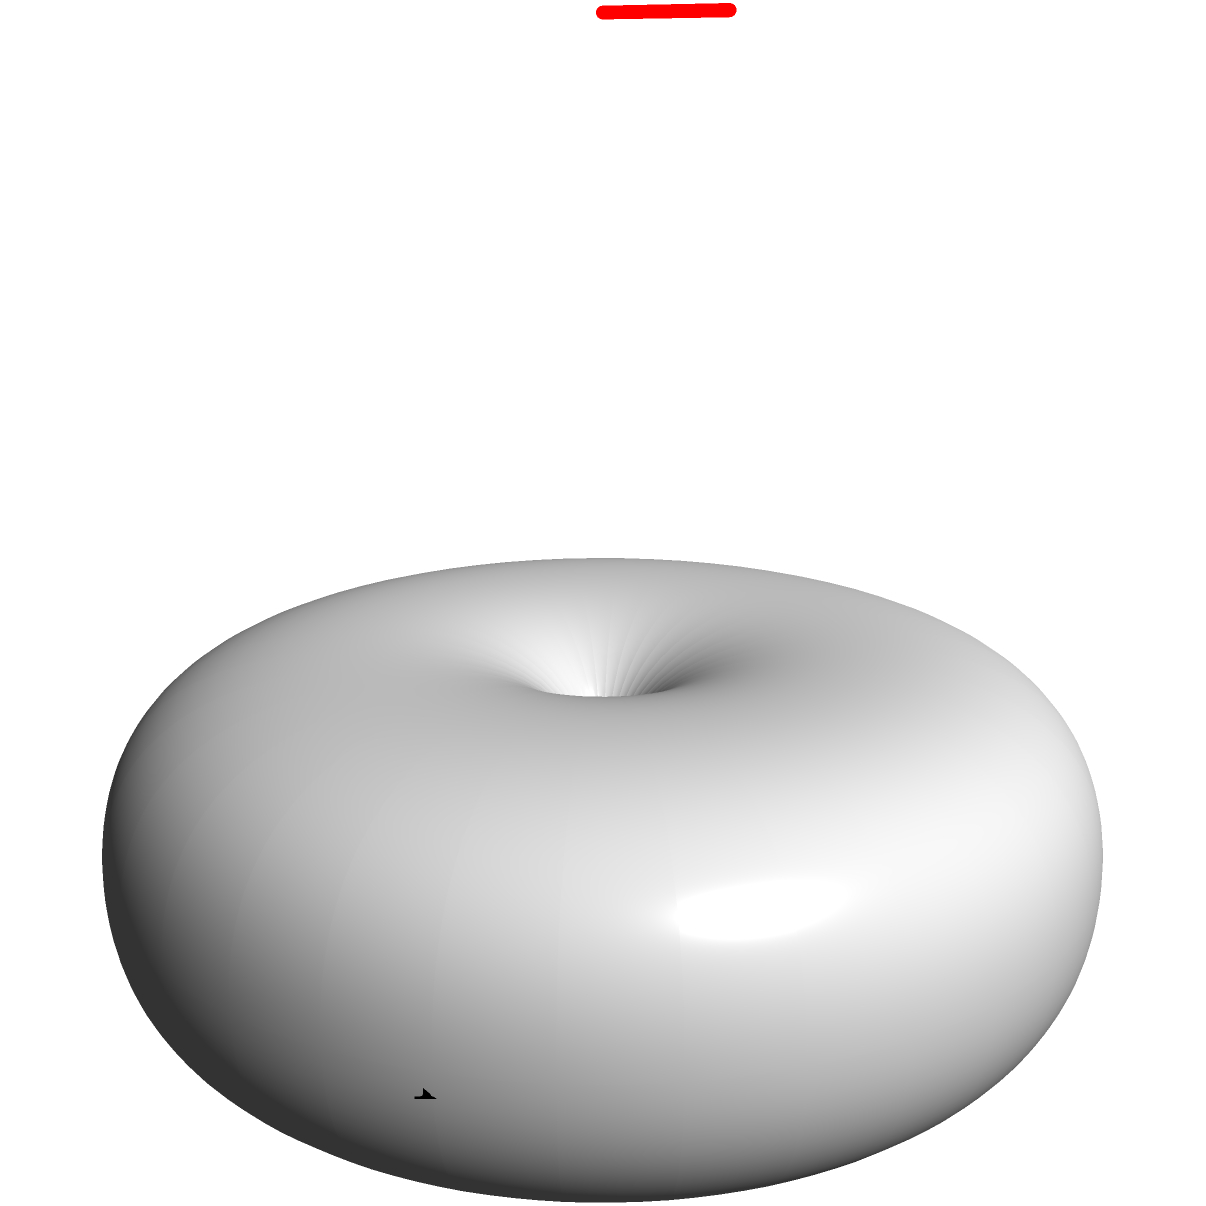In creating a 3D Möbius strip animation for non-linear storytelling, you need to calculate the number of twists required for a seamless loop. If the strip makes one complete revolution in 360 frames, and you want the narrative to repeat every two revolutions with a smooth transition, how many degrees should the strip twist per frame to achieve this effect? To solve this problem, let's break it down step-by-step:

1. One complete revolution of the Möbius strip occurs in 360 frames.

2. We want the narrative to repeat every two revolutions, which means we need a full 360° twist in two revolutions.

3. Two revolutions will take: 
   $2 \times 360 = 720$ frames

4. The total twist angle needed is 360°.

5. To calculate the twist per frame, we divide the total twist angle by the number of frames:

   $\text{Twist per frame} = \frac{\text{Total twist angle}}{\text{Number of frames}}$

   $\text{Twist per frame} = \frac{360°}{720 \text{ frames}}$

6. Simplifying:
   $\text{Twist per frame} = \frac{1}{2}°$ or $0.5°$ per frame

This means that for each frame, the strip should twist by half a degree to achieve a full 360° twist over two complete revolutions, creating a seamless loop for the non-linear narrative.
Answer: $0.5°$ per frame 